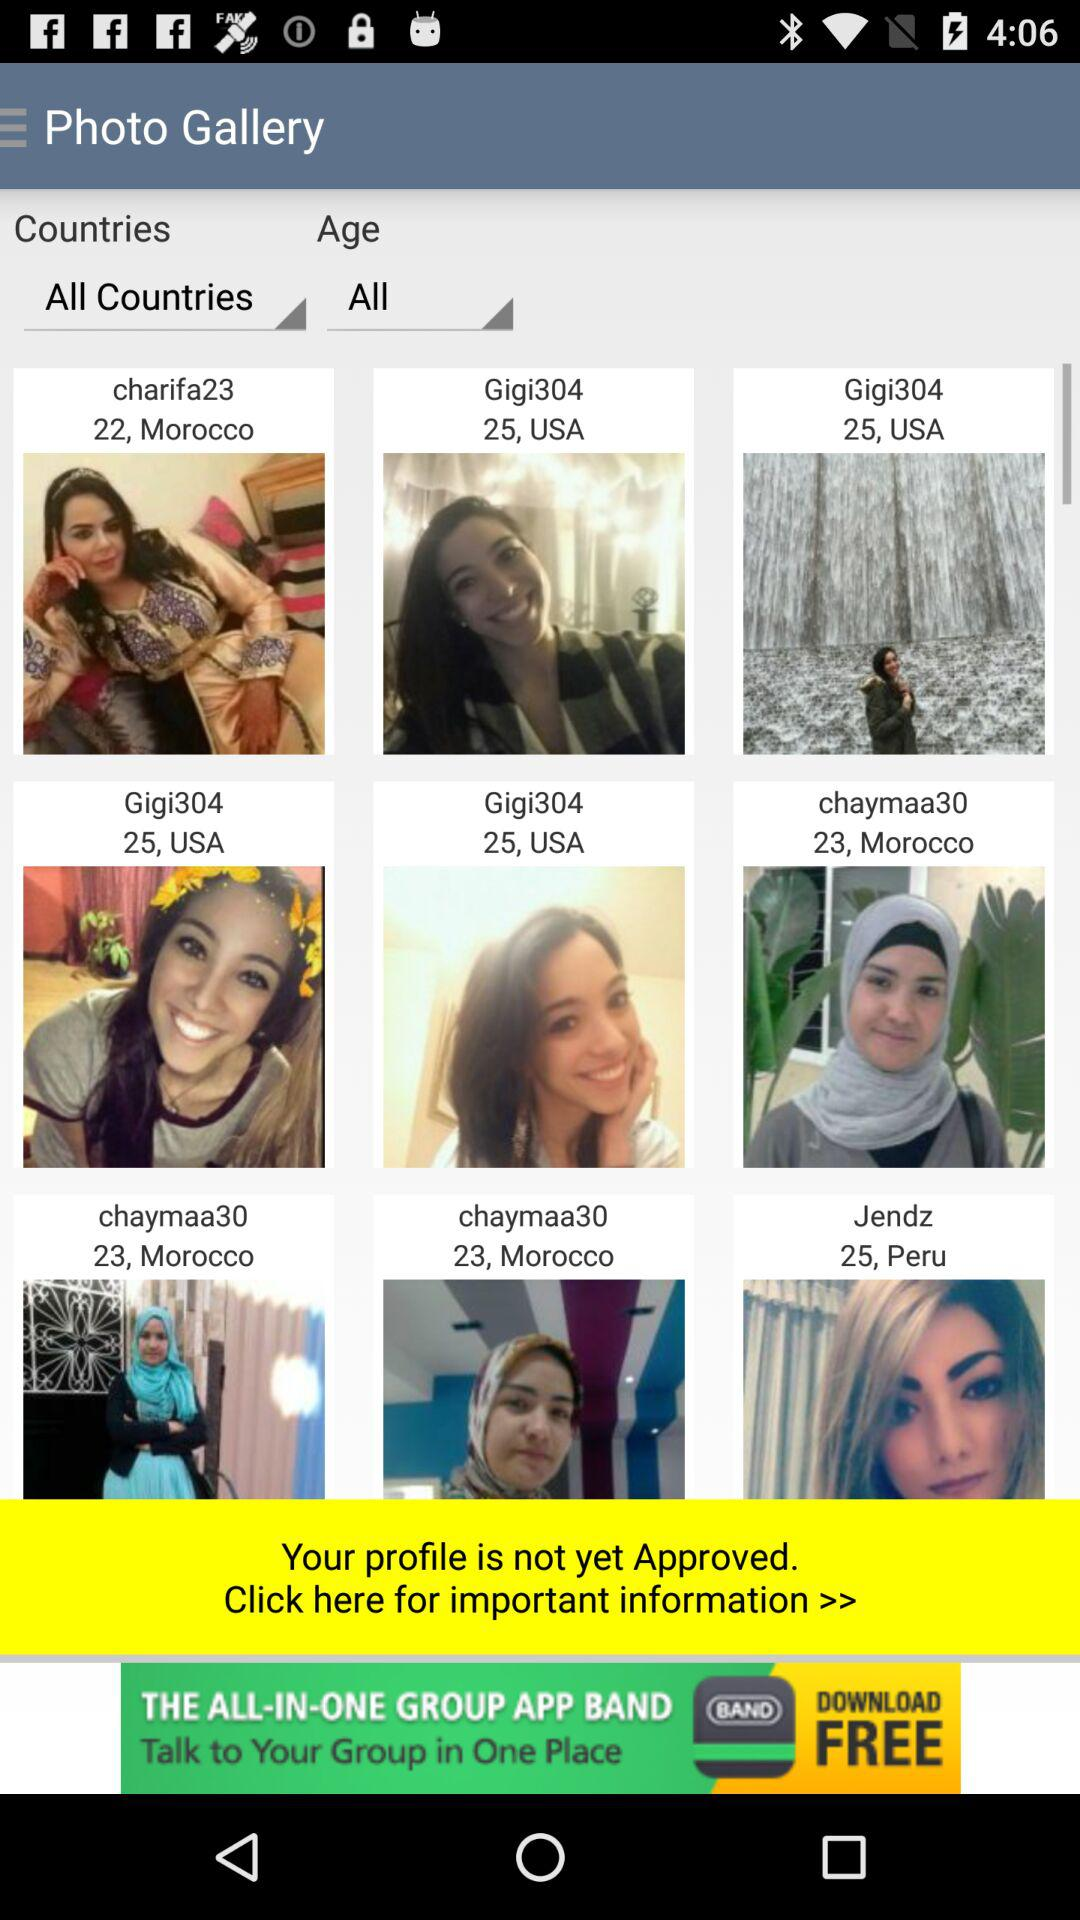Where is "Gigi304" from? "Gigi304" is from the USA. 